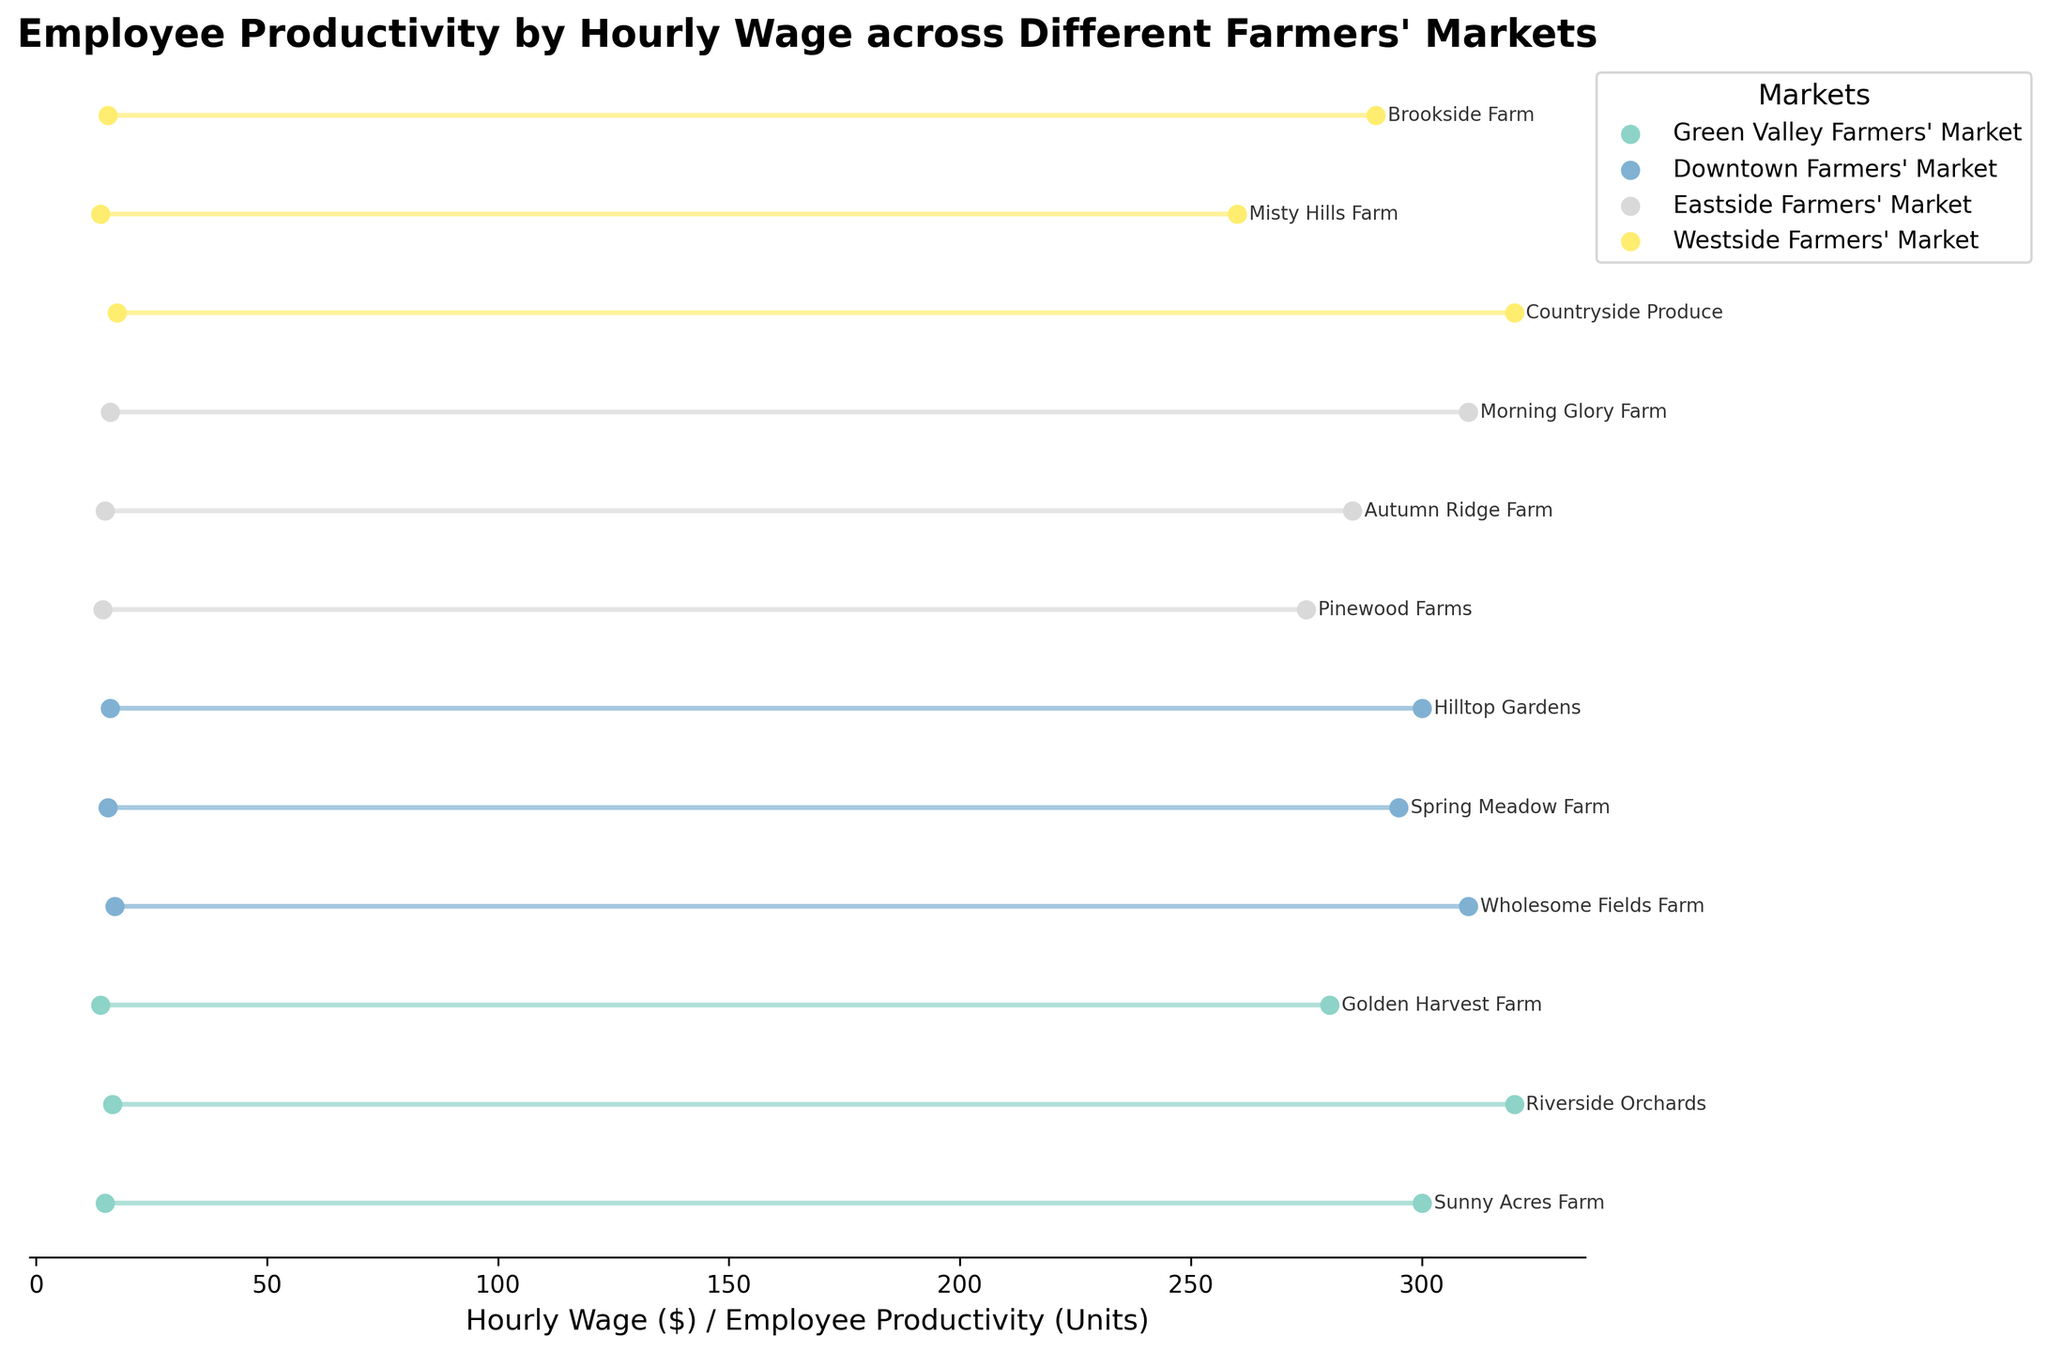What is the title of this figure? The title is usually at the top of the figure and can be read directly. Here, it says "Employee Productivity by Hourly Wage across Different Farmers' Markets"
Answer: Employee Productivity by Hourly Wage across Different Farmers' Markets Which Farmers' Market has the highest variation in hourly wage and employee productivity? Look for the market with the largest spread between the hourly wage and productivity lines. Westside Farmers' Market shows Misty Hills Farm with the widest separation between its points
Answer: Westside Farmers' Market What is the hourly wage for workers at Sunny Acres Farm? Locate Sunny Acres Farm in the Green Valley Farmers' Market section and identify the point marked for 'Hourly Wage ($)'. The value next to 'Hourly Wage' is 15.00
Answer: 15.00 Which market has the highest employee productivity on average? Calculate the average productivity for each market by summing their productivity values and dividing by the number of points. The Downtown Farmers' Market has 910 units (310 + 295 + 305) and three data points, averaging about 308 units
Answer: Downtown Farmers' Market Compare the maximum employee productivity in the Green Valley Farmers' Market and the Eastside Farmers' Market. Which one is higher and by how much? Identify the highest productivity value in each market. Green Valley Farmers' Market has 320 units, and Eastside Farmers' Market also has 310 units. The difference is 10 units
Answer: Green Valley Farmers' Market, by 10 units Which farm has the lowest employee productivity in Downtown Farmers' Market, and what is that productivity? Look at the points for Downtown Farmers' Market and identify the lowest productivity value. Wholesome Fields Farm has the lowest with 295 units
Answer: Wholesome Fields Farm, 295 How do the hourly wages of farms in Westside Farmers' Market compare? Examine the points for Westside Farmers' Market for hourly wages. Countryside Produce, Misty Hills Farm, and Brookside Farm have values of 17.50, 14.00, and 15.50 respectively. Misty Hills Farm pays the least, and Countryside Produce pays the most
Answer: Range from 14.00 to 17.50 Which two farms in the same market have the closest employee productivity levels, and what are those levels? Find pairs of farms in the same market with minimal differences in productivity. In Downtown Farmers' Market, Wholesome Fields Farm and Hilltop Gardens both have 310 units
Answer: Wholesome Fields Farm and Hilltop Gardens, 310 Is there a visible trend between hourly wage and employee productivity across all farmers' markets? By observing the spread of points, generally higher productivity is associated with slightly higher wages, but no strong linear trend is visible
Answer: No clear trend 